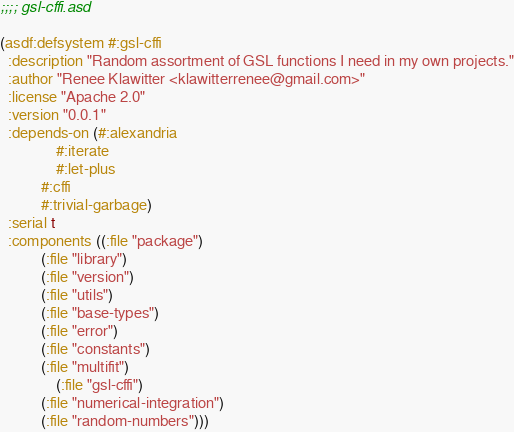<code> <loc_0><loc_0><loc_500><loc_500><_Lisp_>;;;; gsl-cffi.asd

(asdf:defsystem #:gsl-cffi
  :description "Random assortment of GSL functions I need in my own projects."
  :author "Renee Klawitter <klawitterrenee@gmail.com>"
  :license "Apache 2.0"
  :version "0.0.1"
  :depends-on (#:alexandria
               #:iterate
               #:let-plus
	       #:cffi
	       #:trivial-garbage)
  :serial t
  :components ((:file "package")
	       (:file "library")
	       (:file "version")
	       (:file "utils")
	       (:file "base-types")
	       (:file "error")
	       (:file "constants")
	       (:file "multifit")
               (:file "gsl-cffi")
	       (:file "numerical-integration")
	       (:file "random-numbers")))

</code> 